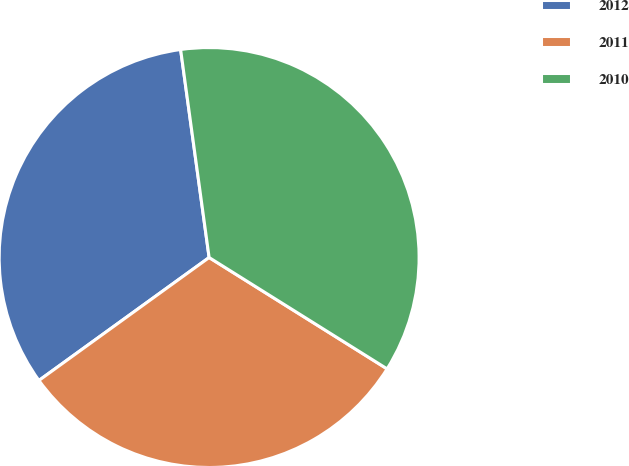Convert chart. <chart><loc_0><loc_0><loc_500><loc_500><pie_chart><fcel>2012<fcel>2011<fcel>2010<nl><fcel>32.79%<fcel>31.15%<fcel>36.07%<nl></chart> 